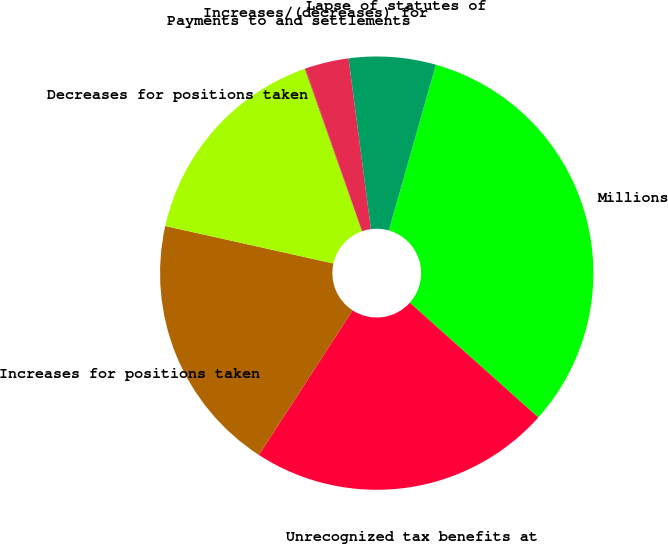Convert chart to OTSL. <chart><loc_0><loc_0><loc_500><loc_500><pie_chart><fcel>Millions<fcel>Unrecognized tax benefits at<fcel>Increases for positions taken<fcel>Decreases for positions taken<fcel>Payments to and settlements<fcel>Increases/(decreases) for<fcel>Lapse of statutes of<nl><fcel>32.2%<fcel>22.55%<fcel>19.34%<fcel>16.12%<fcel>0.05%<fcel>3.26%<fcel>6.48%<nl></chart> 